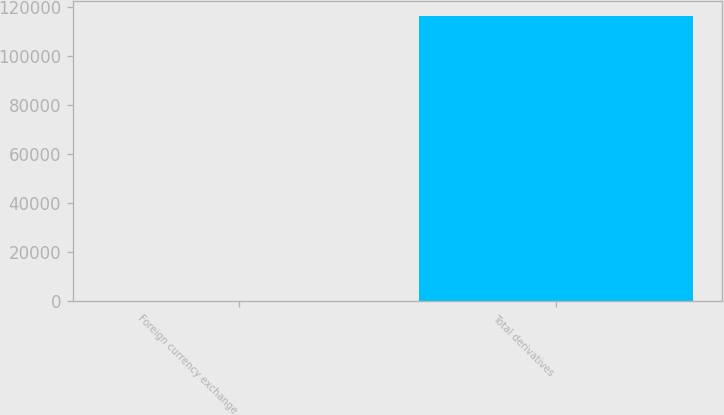Convert chart. <chart><loc_0><loc_0><loc_500><loc_500><bar_chart><fcel>Foreign currency exchange<fcel>Total derivatives<nl><fcel>379<fcel>116374<nl></chart> 